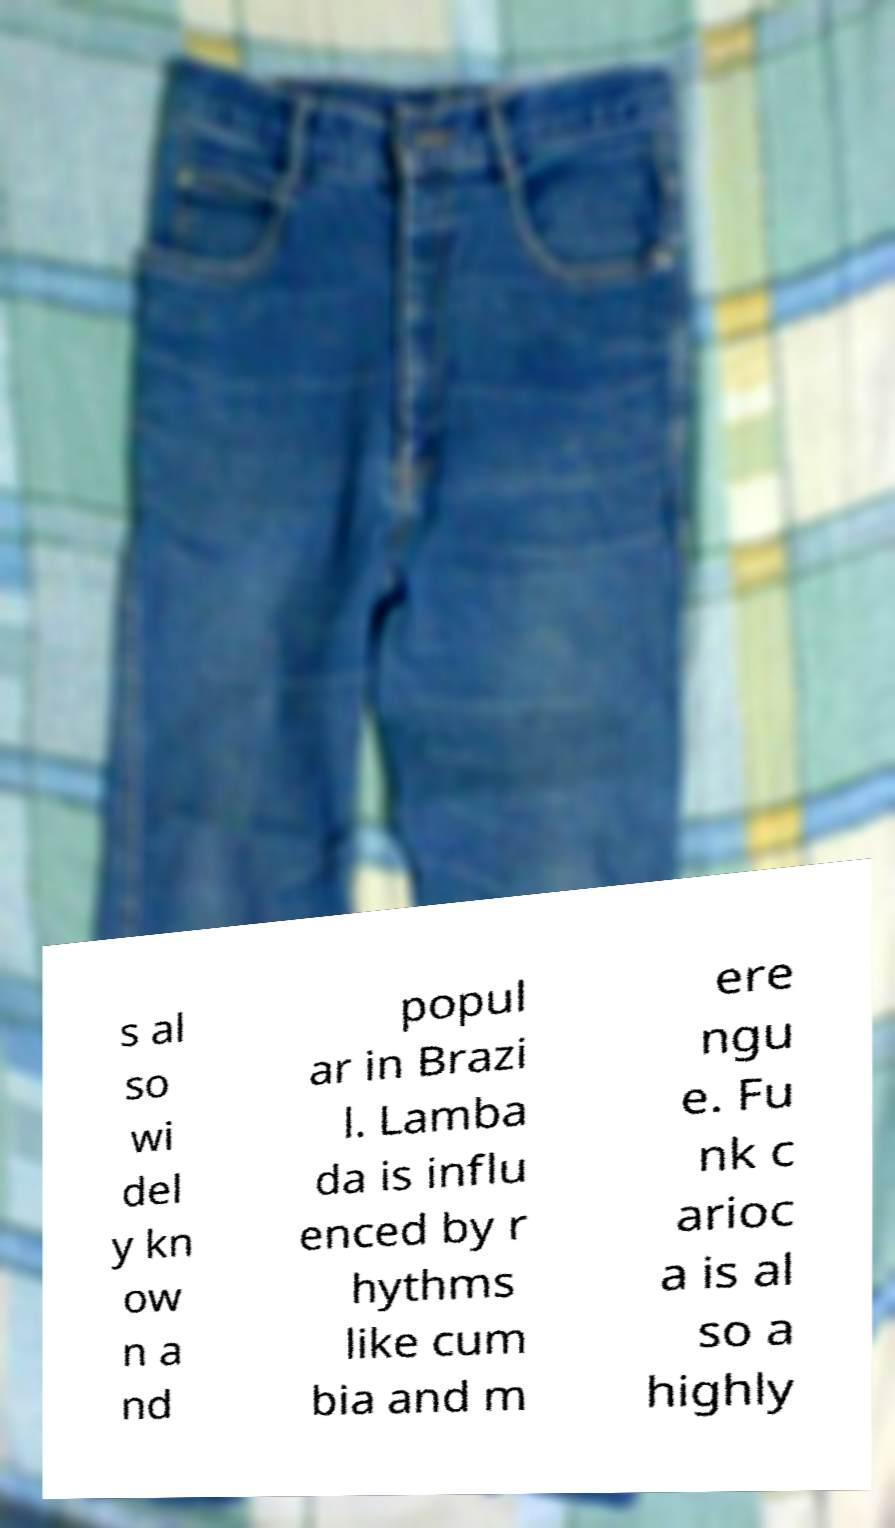For documentation purposes, I need the text within this image transcribed. Could you provide that? s al so wi del y kn ow n a nd popul ar in Brazi l. Lamba da is influ enced by r hythms like cum bia and m ere ngu e. Fu nk c arioc a is al so a highly 